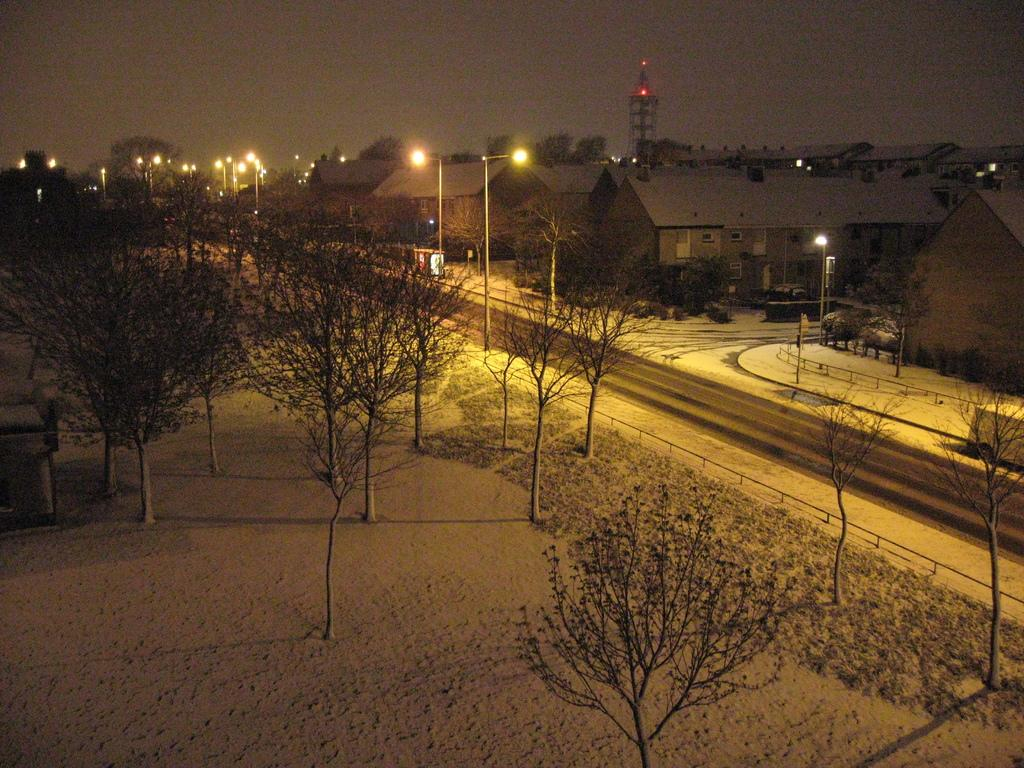What type of view is provided in the image? The image is a top view. What can be seen on the ground in the image? There are dry trees and a road in the image. What type of structures are present in the image? There are houses and a tower in the image. What is the color of the sky in the background of the image? The sky in the background is dark. What type of whip is being used to create the image? There is no whip present in the image; it is a photograph or digital representation. Can you describe the picture hanging on the wall in the image? There is no picture hanging on the wall in the image; the focus is on the dry trees, road, houses, and tower. 